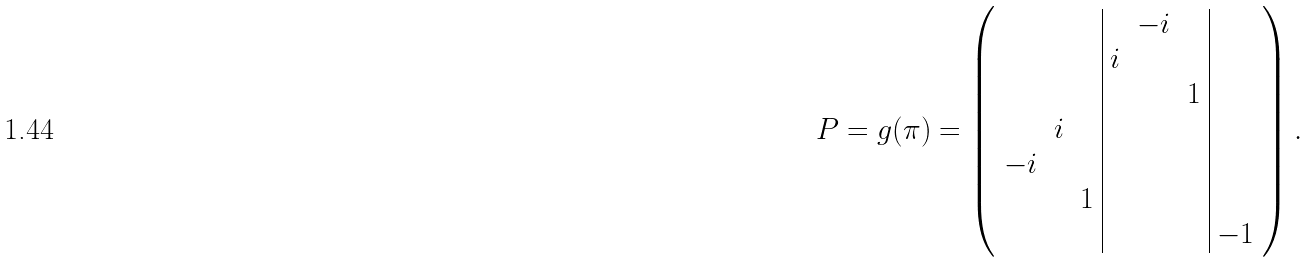Convert formula to latex. <formula><loc_0><loc_0><loc_500><loc_500>P = g ( \pi ) = \left ( \begin{array} { c c c | c c c | c } & & & & - i & & \\ & & & i & & & \\ & & & & & 1 & \\ & i & & & & & \\ - i & & & & & & \\ & & 1 & & & & \\ & & & & & & - 1 \end{array} \right ) .</formula> 